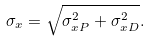<formula> <loc_0><loc_0><loc_500><loc_500>\sigma _ { x } = \sqrt { \sigma _ { x P } ^ { 2 } + \sigma _ { x D } ^ { 2 } } .</formula> 